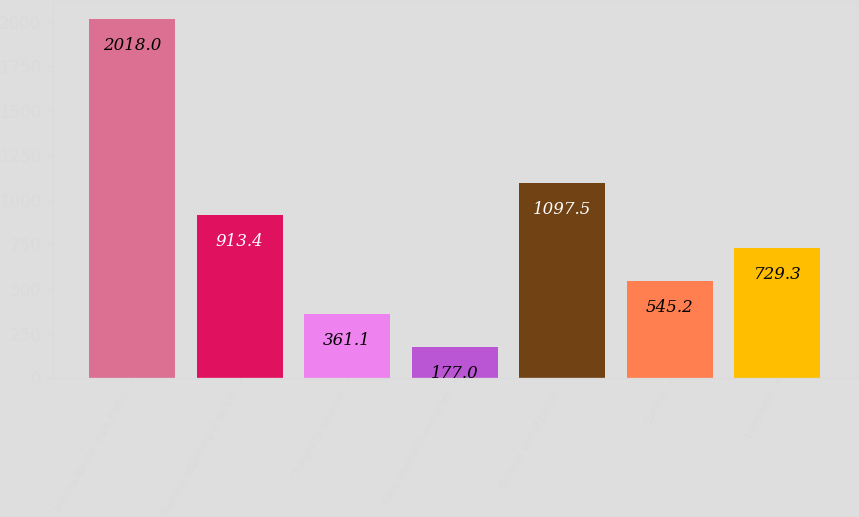Convert chart to OTSL. <chart><loc_0><loc_0><loc_500><loc_500><bar_chart><fcel>Millions for the Years Ended<fcel>Balance beginning of period<fcel>Charges to expense<fcel>Cash payments and other<fcel>Balance end of period<fcel>Current<fcel>Long-term<nl><fcel>2018<fcel>913.4<fcel>361.1<fcel>177<fcel>1097.5<fcel>545.2<fcel>729.3<nl></chart> 